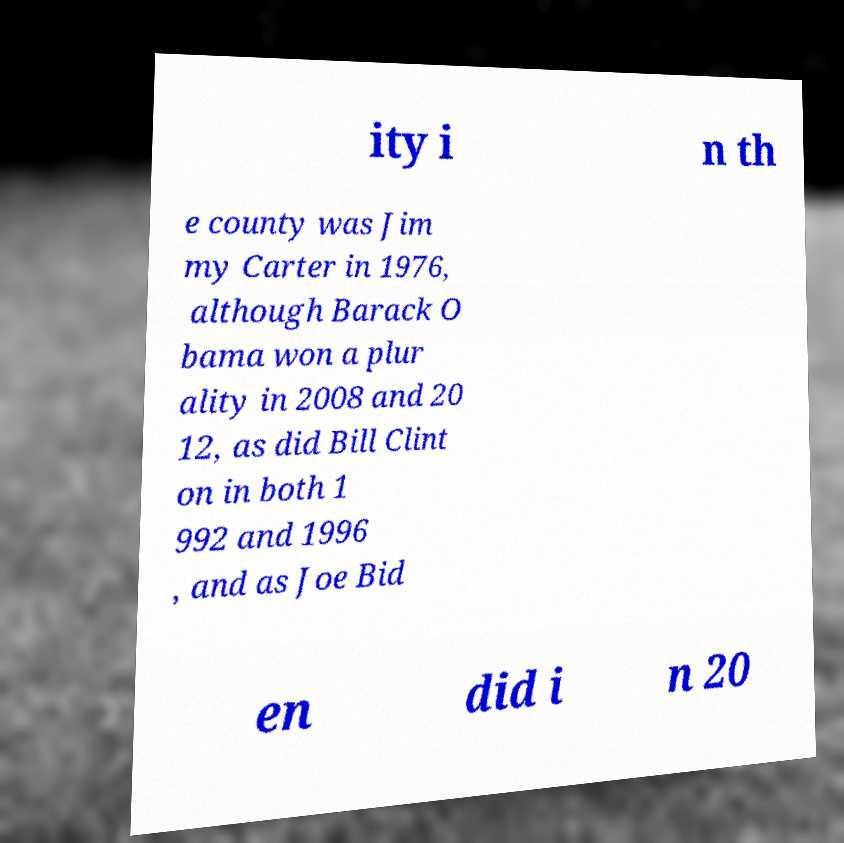There's text embedded in this image that I need extracted. Can you transcribe it verbatim? ity i n th e county was Jim my Carter in 1976, although Barack O bama won a plur ality in 2008 and 20 12, as did Bill Clint on in both 1 992 and 1996 , and as Joe Bid en did i n 20 